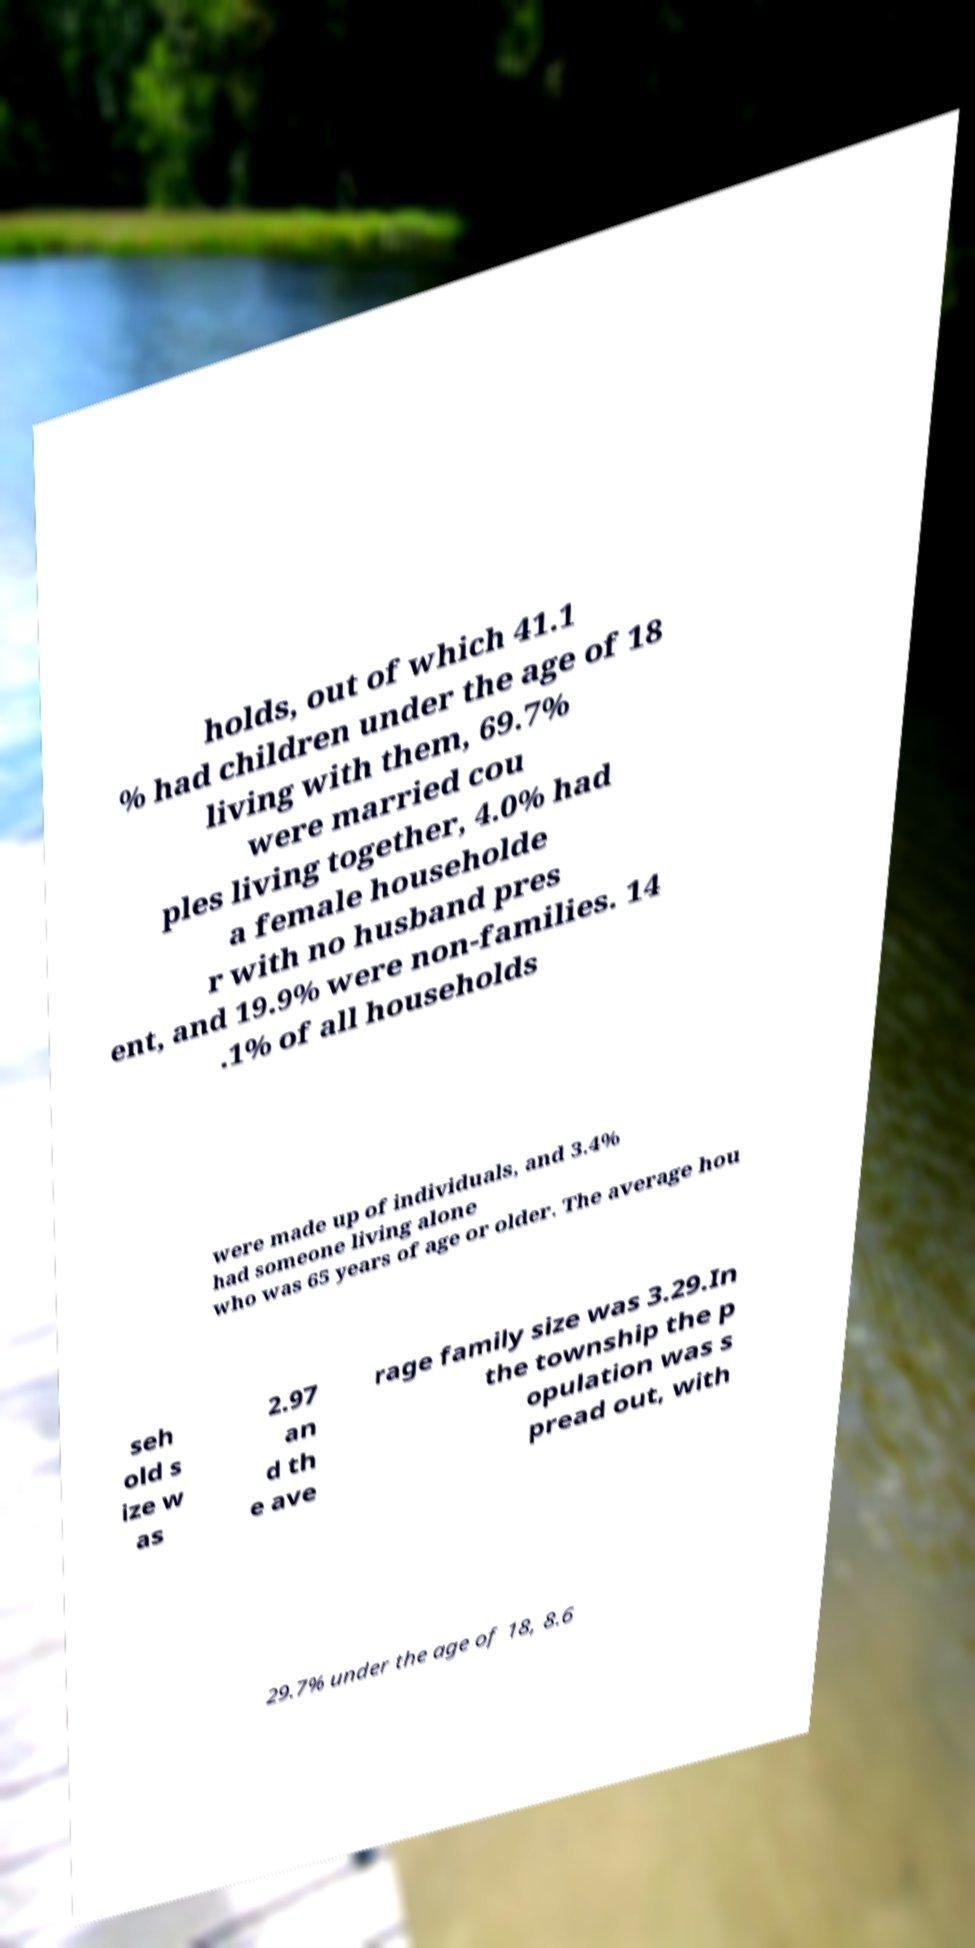What messages or text are displayed in this image? I need them in a readable, typed format. holds, out of which 41.1 % had children under the age of 18 living with them, 69.7% were married cou ples living together, 4.0% had a female householde r with no husband pres ent, and 19.9% were non-families. 14 .1% of all households were made up of individuals, and 3.4% had someone living alone who was 65 years of age or older. The average hou seh old s ize w as 2.97 an d th e ave rage family size was 3.29.In the township the p opulation was s pread out, with 29.7% under the age of 18, 8.6 